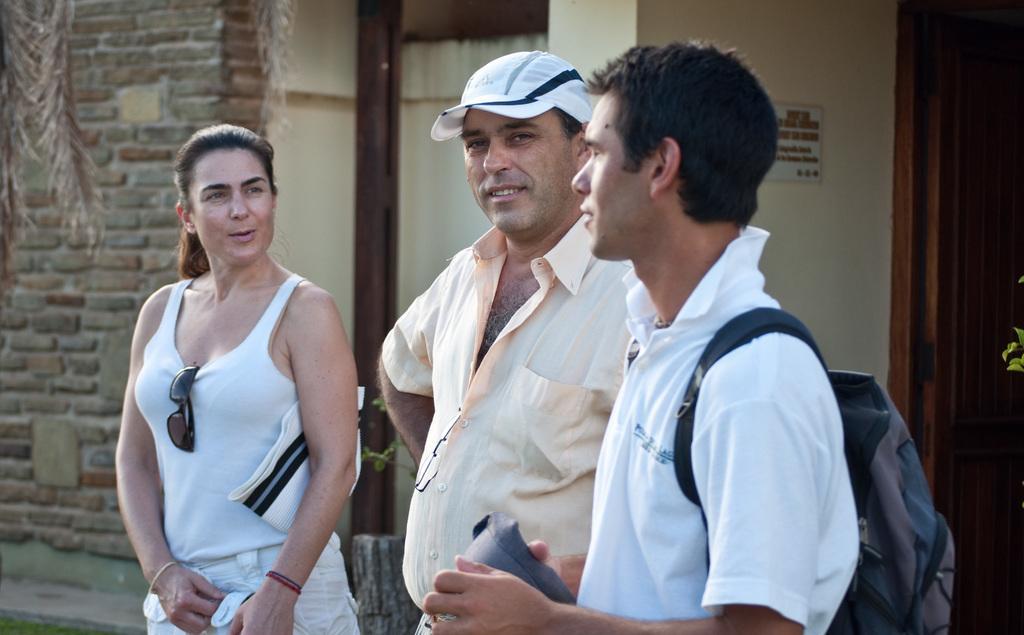In one or two sentences, can you explain what this image depicts? This image consists of three persons. On the left, we can see a woman wearing a white dress. In the front, we can see a man wearing a backpack. In the background, there is a house along with a door and a window. 